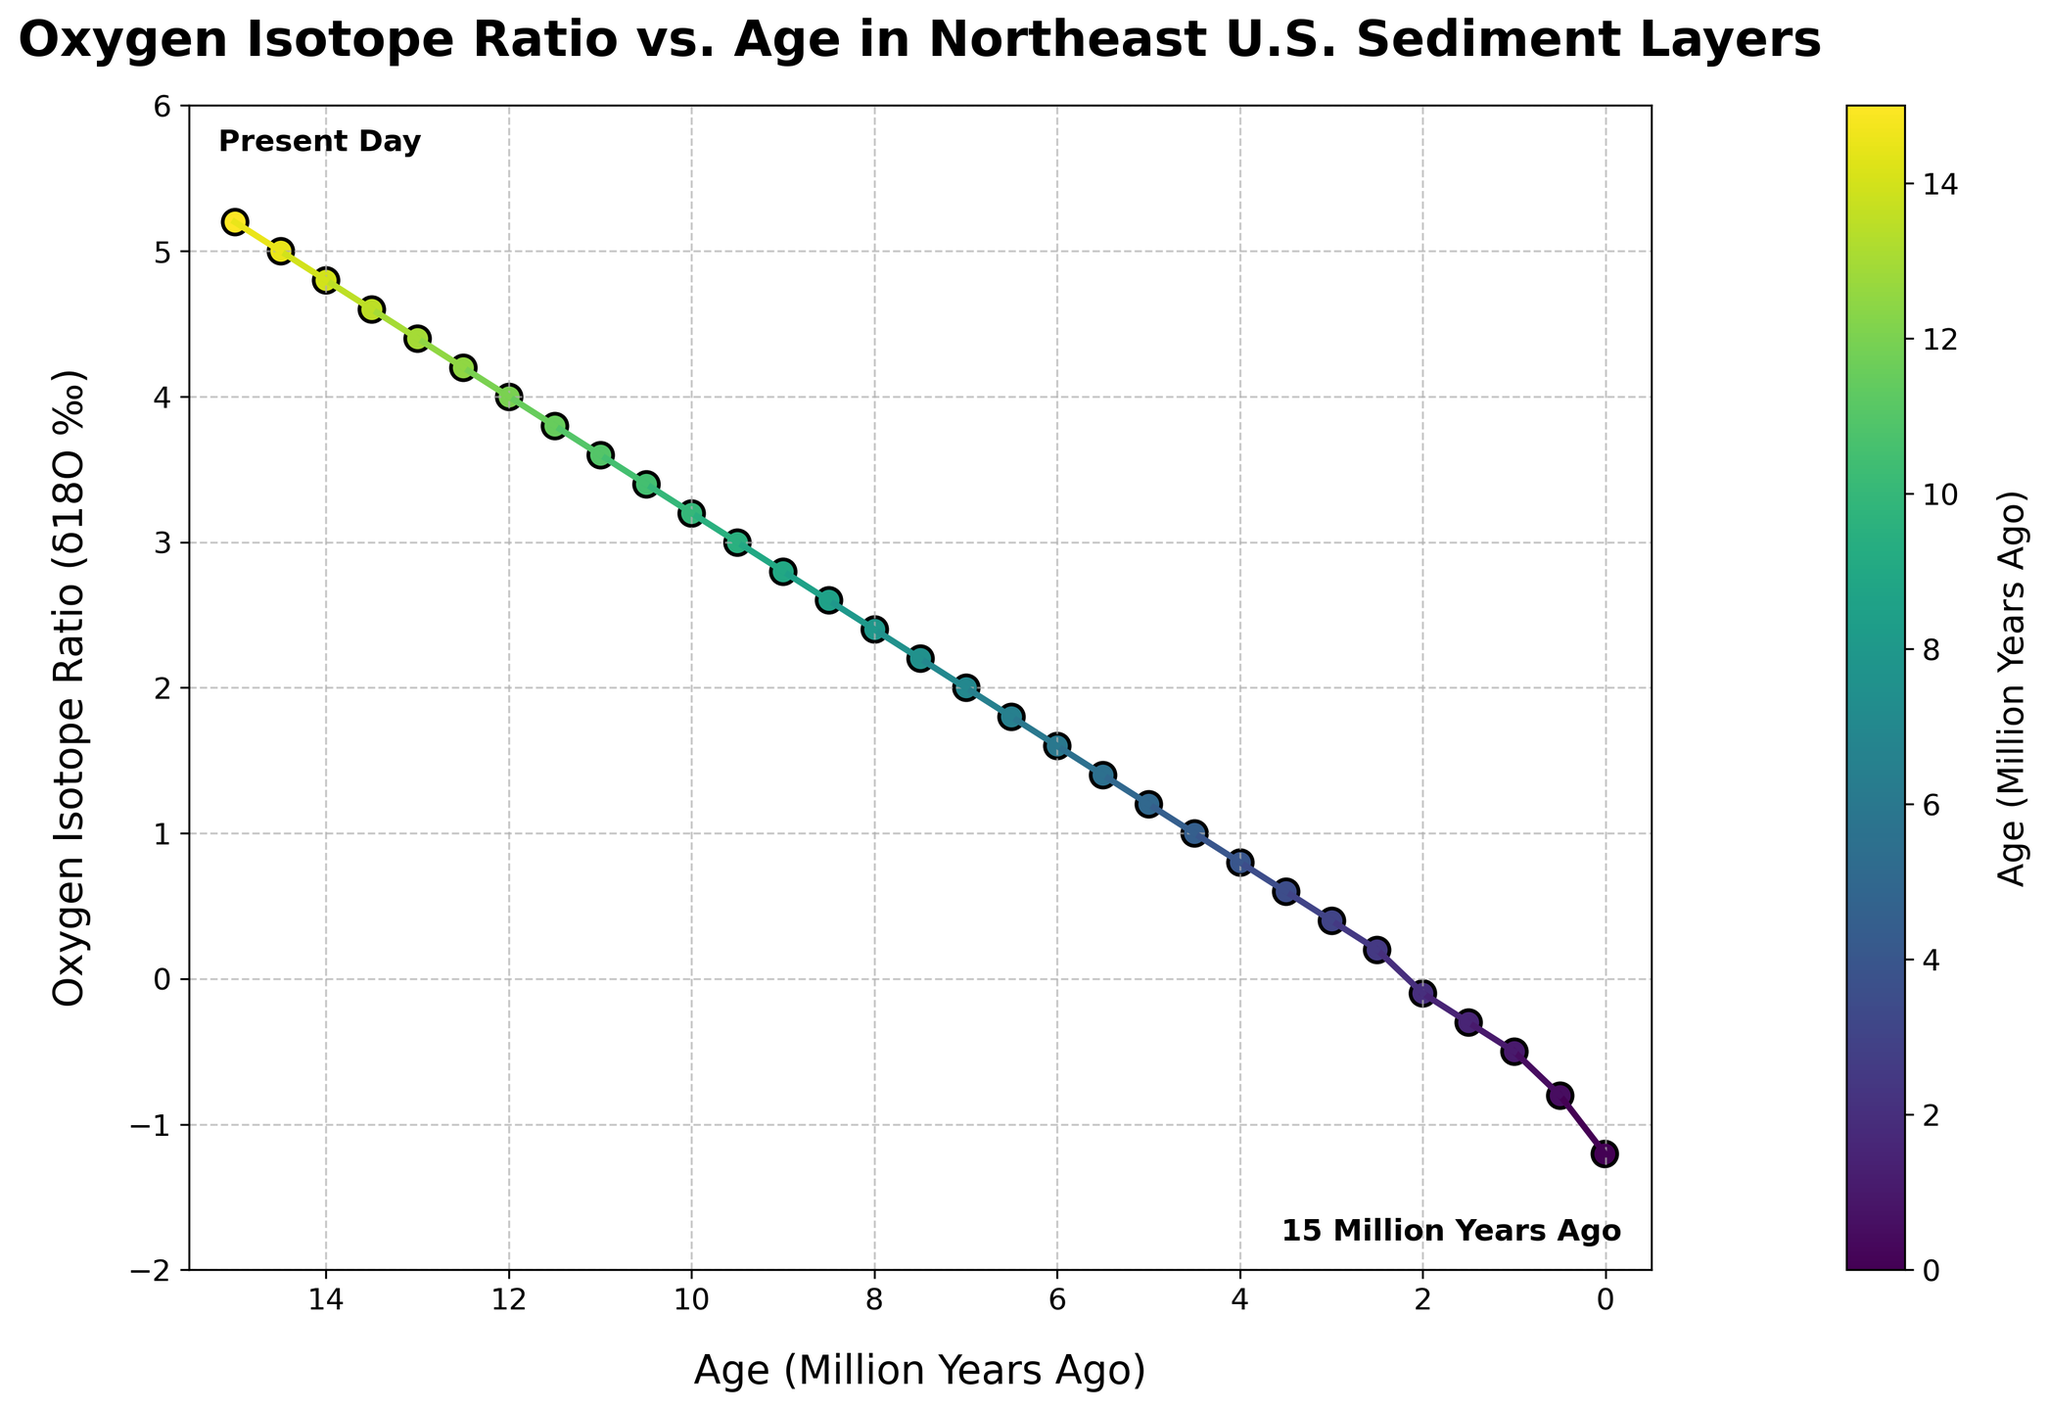When does the Oxygen Isotope Ratio reach a value of 2.0‰? Look for the data point where the Oxygen Isotope Ratio (δ18O ‰) equals 2.0. According to the plotted data, this occurs at 7.0 million years ago (Mya).
Answer: 7.0 Mya What is the trend of the Oxygen Isotope Ratio over time? Observe the overall shape and direction of the plotted line. The Oxygen Isotope Ratio (δ18O ‰) shows an increasing trend from -1.2‰ at 0.01 Mya to 5.2‰ at 15 Mya.
Answer: Increasing Which time period has the sharpest increase in the Oxygen Isotope Ratio? Identify the segment with the steepest slope. Between 0.01 Mya (-1.2‰) and 1.0 Mya (-0.5‰), the rise is most pronounced. Calculate the difference: (-0.5 - (-1.2)) / (1.0 - 0.01). The ratio change per million years in this interval is approximately the sharpest.
Answer: 0.01 Mya to 1.0 Mya What is the average Oxygen Isotope Ratio over the first 5 million years? Sum the Oxygen Isotope Ratios for the first 5 Mya and divide by the number of data points. The values are -1.2, -0.8, -0.5, -0.3, -0.1, 0.2, 0.4, 0.6, 0.8, and 1.0. Summing these gives 0.1. There are 10 points, so the average is 0.1 / 10 = 0.01‰.
Answer: 0.01‰ Is there a period where the Oxygen Isotope Ratio remained constant? Examine if there is any horizontal segment in the plotted line, indicating a period with no change. Based on the graph, the ratio consistently changes, indicating no period of constancy.
Answer: No By how much did the Oxygen Isotope Ratio change between 10 and 15 million years ago? Find the difference in δ18O ‰ values between 10 (3.2‰) and 15 Mya (5.2‰). Subtract to determine the change: 5.2‰ - 3.2‰ = 2.0‰.
Answer: 2.0‰ What colors are used to identify data points near 0 million years ago and 15 million years ago? Check the color gradient for the respective time periods. The color near 0 Mya is at one end of the gradient, and the color for 15 Mya is on the opposite end. Based on the plot's colormap, present-day (0 Mya) is represented by a yellow-green color, while 15 Mya is represented by a dark blue-violet color.
Answer: Yellow-green (0 Mya) and dark blue-violet (15 Mya) What is the Oxygen Isotope Ratio at 10 million years ago compared to 5 million years ago? Refer to the plotted data points for 10 Mya and 5 Mya. At 10 Mya, δ18O ‰ is 3.2; at 5 Mya, δ18O ‰ is 1.2. Thus, the ratio at 10 Mya is 2.0‰ higher than at 5 Mya.
Answer: Higher by 2.0‰ How long did it take for the Oxygen Isotope Ratio to increase from 0.4‰ to 2.4‰? Identify the ages corresponding to the two values: 3.0 Mya (0.4‰) and 8.0 Mya (2.4‰). Subtract the latter from the former: 8.0 Mya - 3.0 Mya = 5.0 million years.
Answer: 5.0 million years 